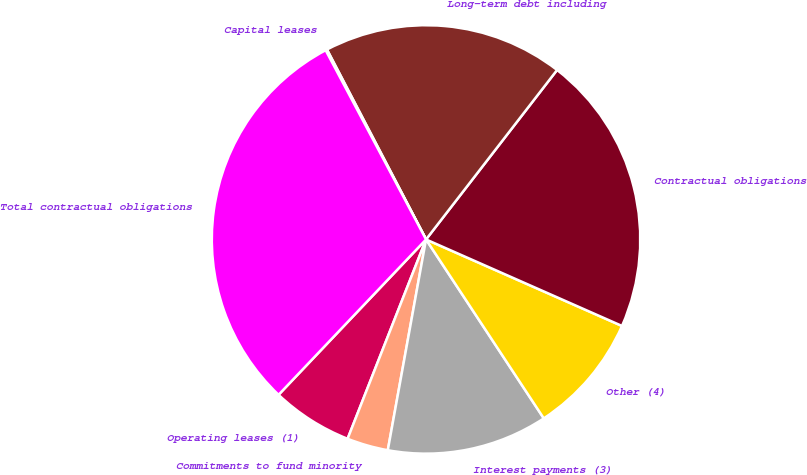<chart> <loc_0><loc_0><loc_500><loc_500><pie_chart><fcel>Operating leases (1)<fcel>Commitments to fund minority<fcel>Interest payments (3)<fcel>Other (4)<fcel>Contractual obligations<fcel>Long-term debt including<fcel>Capital leases<fcel>Total contractual obligations<nl><fcel>6.12%<fcel>3.11%<fcel>12.12%<fcel>9.12%<fcel>21.14%<fcel>18.13%<fcel>0.11%<fcel>30.15%<nl></chart> 